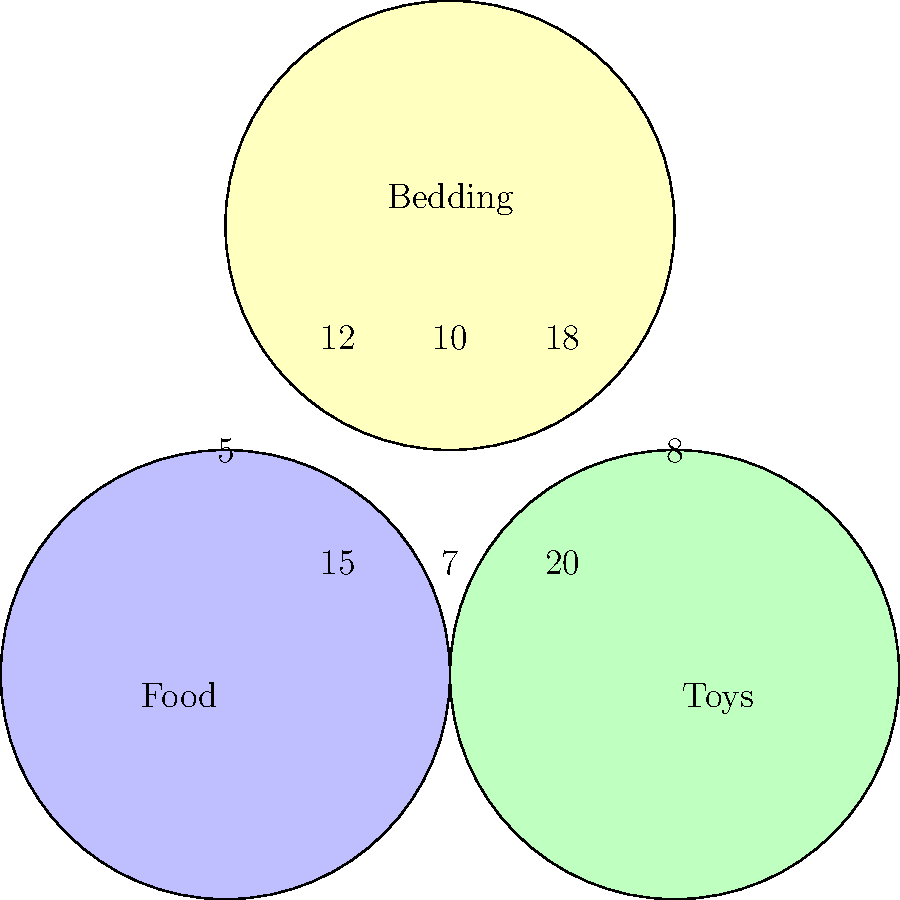Based on the Venn diagram showing the distribution of organic pet products donated, how many donations included both food and bedding, but not toys? To solve this problem, we need to follow these steps:

1. Understand what the question is asking: We're looking for donations that include both food and bedding, but not toys.

2. Locate the relevant section in the Venn diagram: This would be the area where the circles for "Food" and "Bedding" overlap, but doesn't include the "Toys" circle.

3. Identify the number in that section: In the overlap between "Food" and "Bedding" circles, excluding the central area where all three circles overlap, we see the number 12.

4. Interpret the result: This means that there were 12 donations that included both food and bedding, but not toys.
Answer: 12 